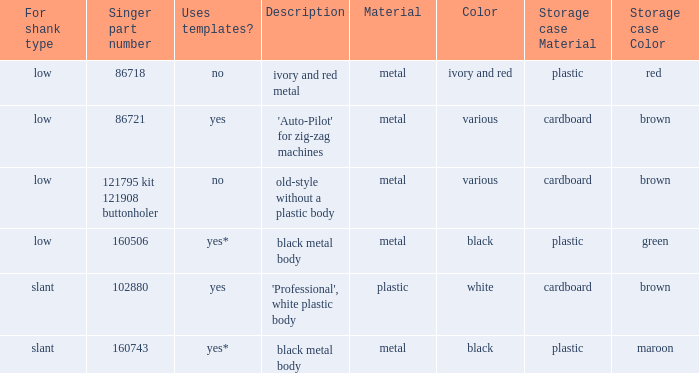What are all the distinct definitions for the buttonholer with a cardboard case for storage and a low shank kind? 'Auto-Pilot' for zig-zag machines, old-style without a plastic body. 